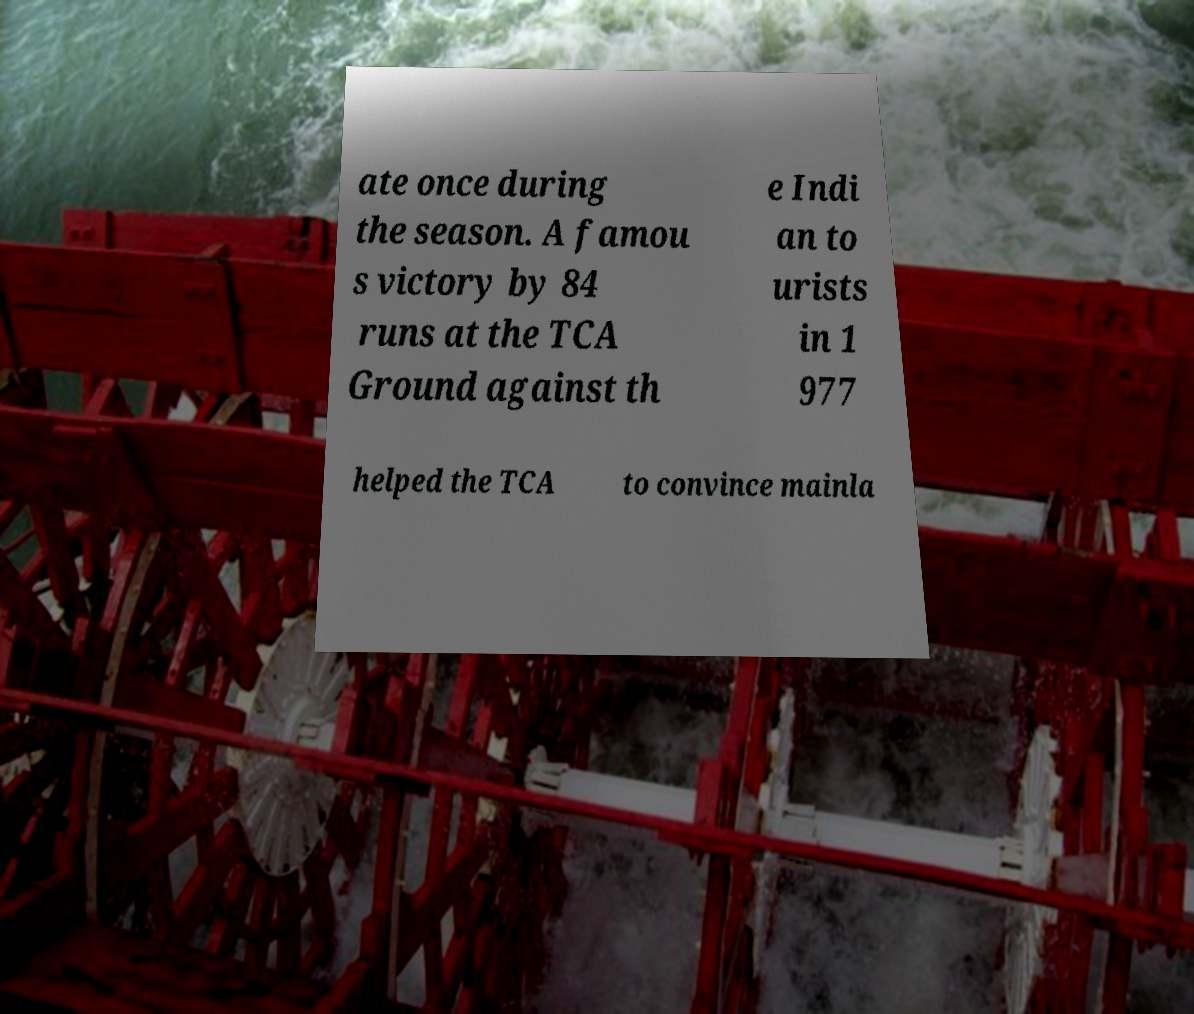Could you assist in decoding the text presented in this image and type it out clearly? ate once during the season. A famou s victory by 84 runs at the TCA Ground against th e Indi an to urists in 1 977 helped the TCA to convince mainla 